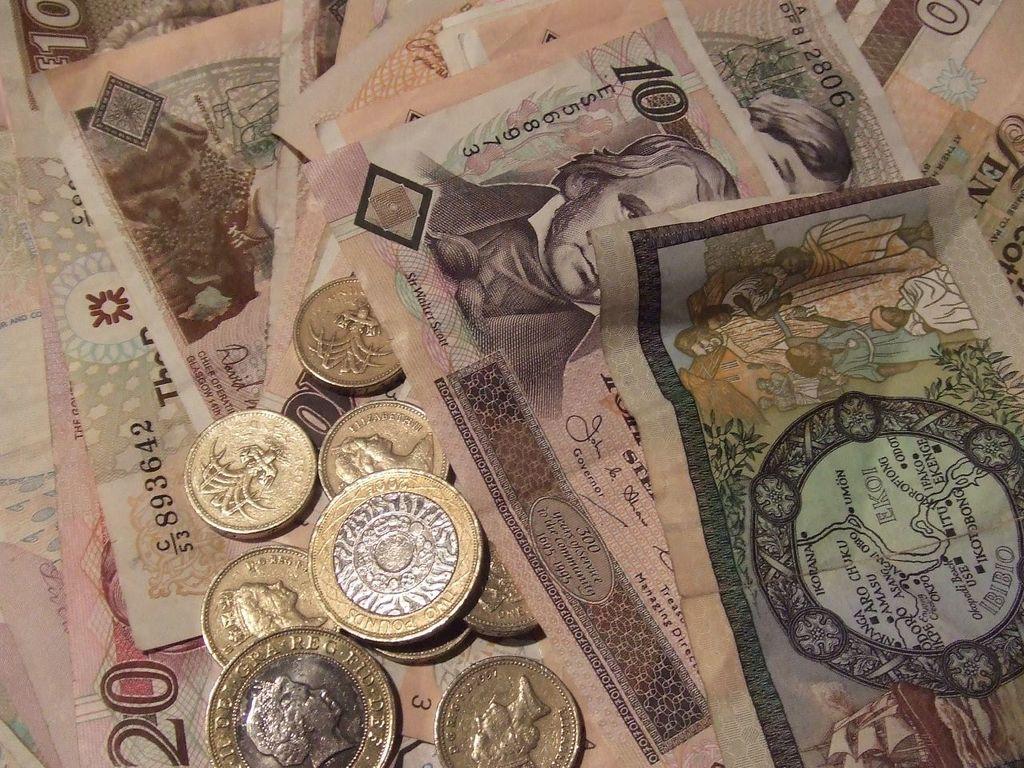Is this a picture of money?
Keep it short and to the point. Yes. What is the serial number written on the bill?
Your response must be concise. Es568973. 